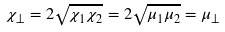Convert formula to latex. <formula><loc_0><loc_0><loc_500><loc_500>\chi _ { \bot } = 2 \sqrt { \chi _ { 1 } \chi _ { 2 } } = 2 \sqrt { \mu _ { 1 } \mu _ { 2 } } = \mu _ { \bot }</formula> 